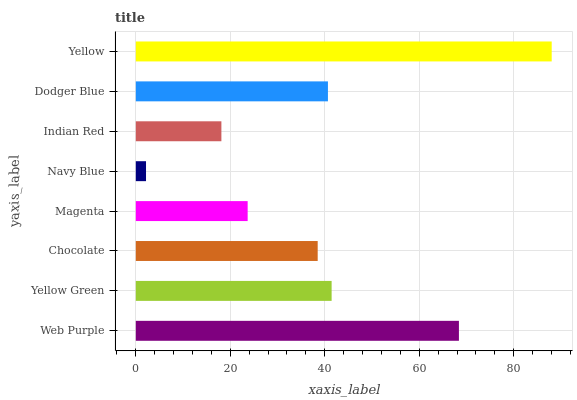Is Navy Blue the minimum?
Answer yes or no. Yes. Is Yellow the maximum?
Answer yes or no. Yes. Is Yellow Green the minimum?
Answer yes or no. No. Is Yellow Green the maximum?
Answer yes or no. No. Is Web Purple greater than Yellow Green?
Answer yes or no. Yes. Is Yellow Green less than Web Purple?
Answer yes or no. Yes. Is Yellow Green greater than Web Purple?
Answer yes or no. No. Is Web Purple less than Yellow Green?
Answer yes or no. No. Is Dodger Blue the high median?
Answer yes or no. Yes. Is Chocolate the low median?
Answer yes or no. Yes. Is Yellow Green the high median?
Answer yes or no. No. Is Yellow the low median?
Answer yes or no. No. 